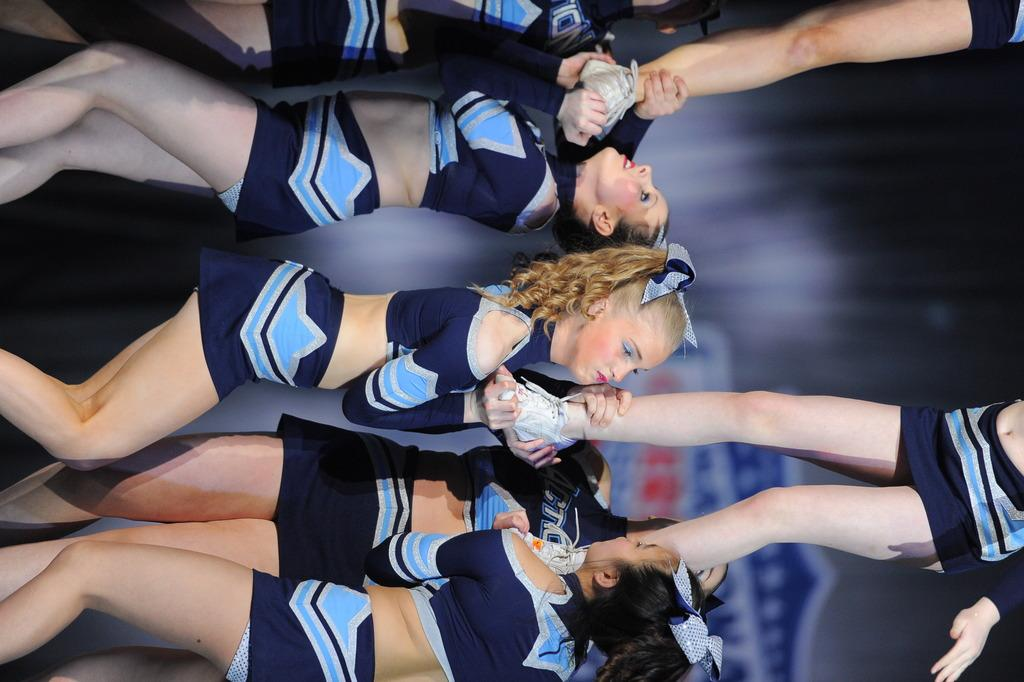What is the main subject of the image? The main subject of the image is groups of persons standing. Can you describe the background of the image? The background of the image is blurred. How many pizzas are being held by the kitten in the image? There is no kitten or pizza present in the image. 